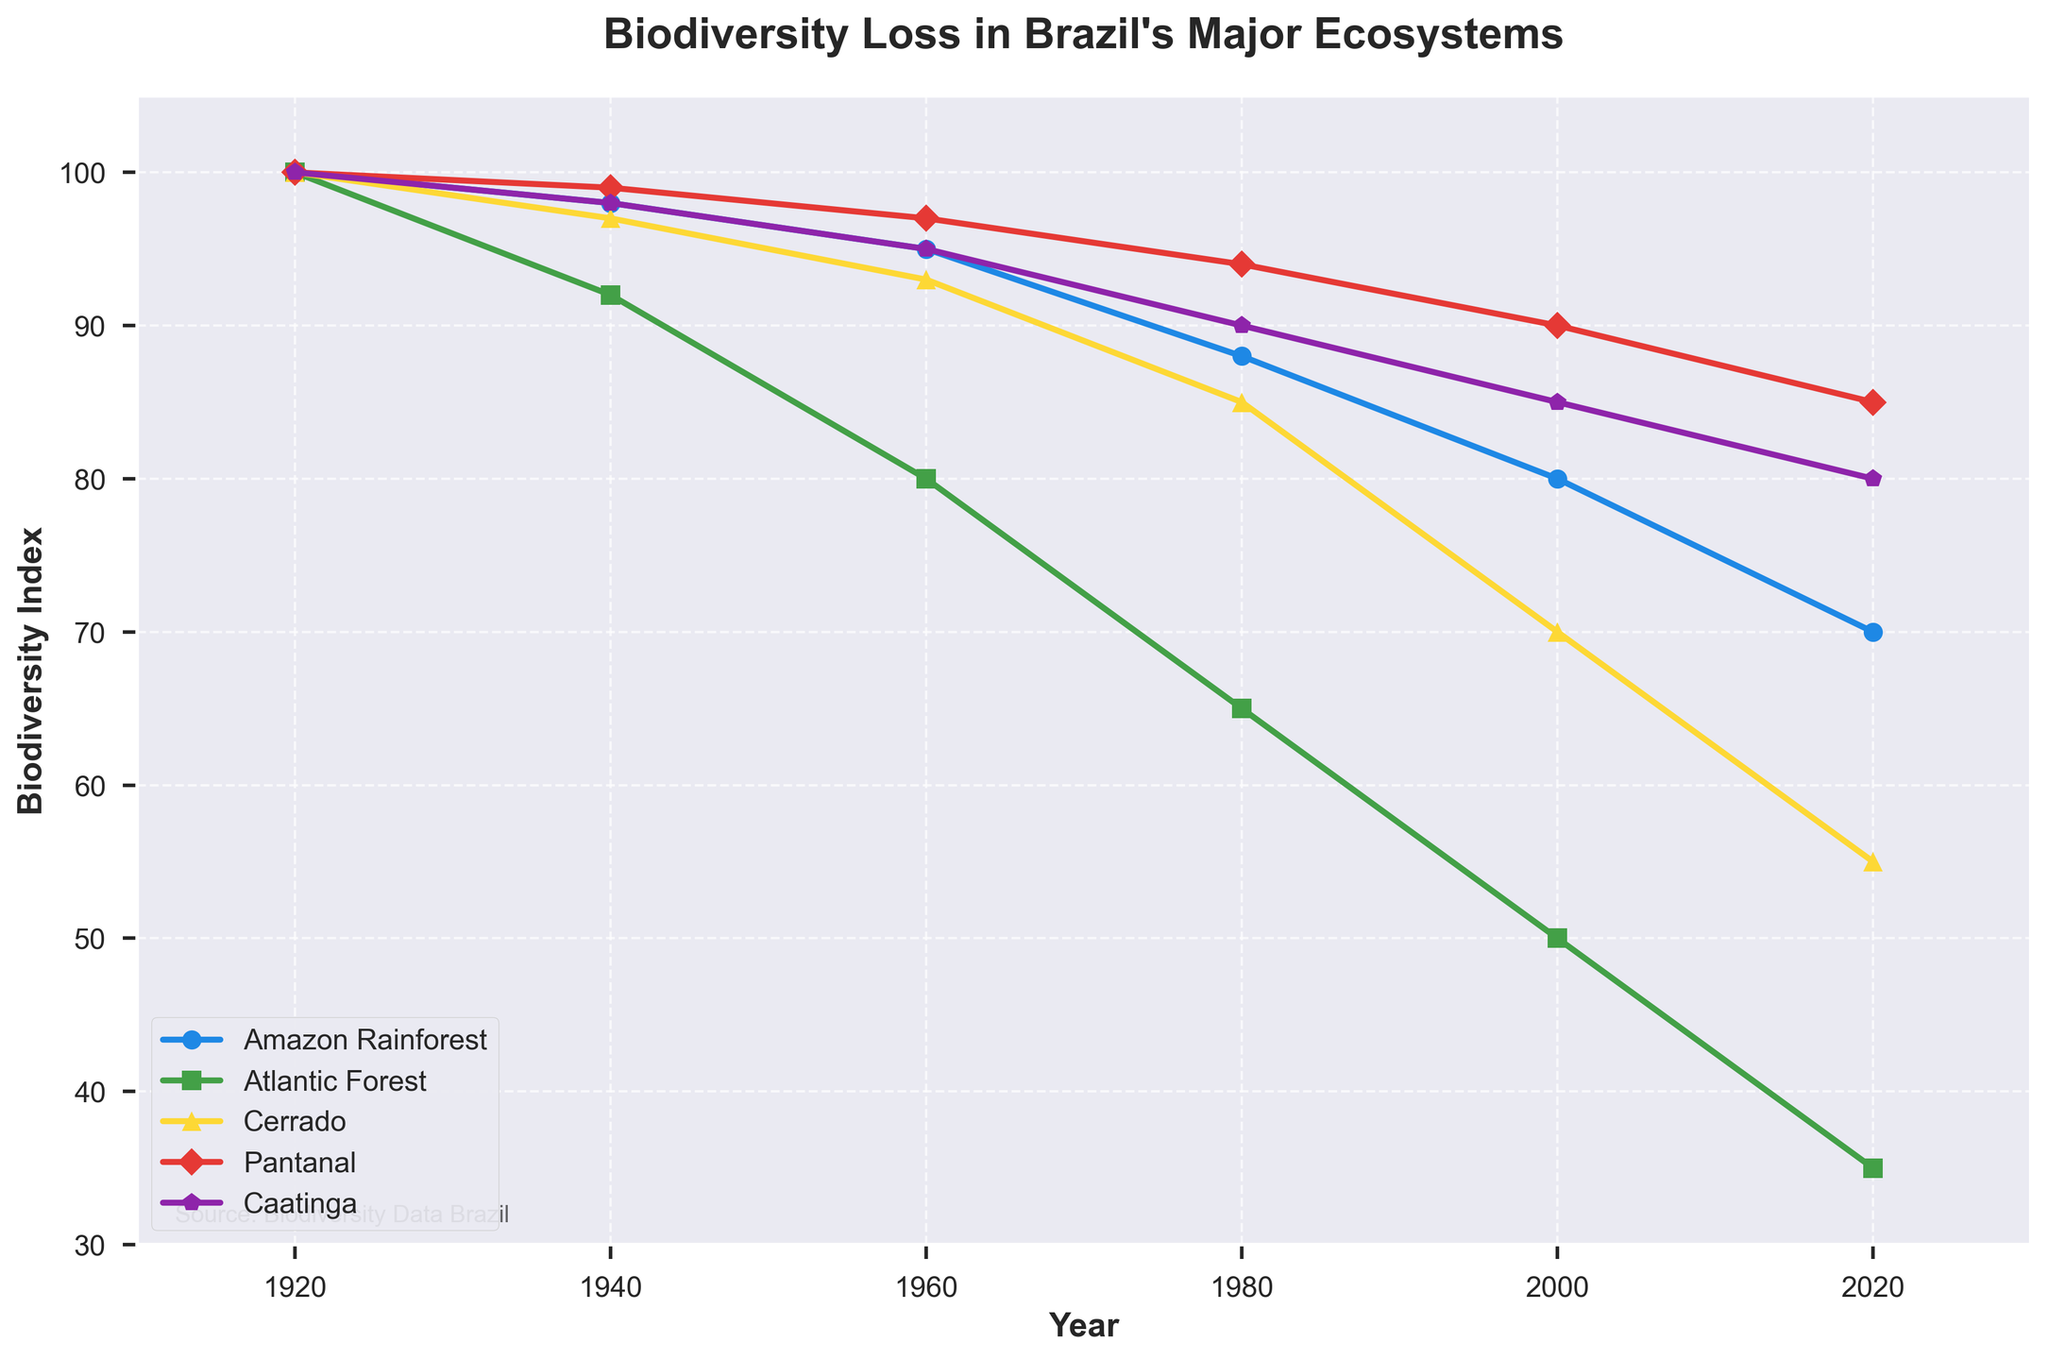What is the trend of biodiversity loss in the Amazon Rainforest over the last century? The line representing the Amazon Rainforest shows a consistent downward trend from 100 in 1920 to 70 in 2020. This indicates a steady decline in biodiversity over the last century.
Answer: A consistent downward trend Which ecosystem has the least biodiversity loss in 2020? In 2020, the Pantanal's line is the highest on the chart among all ecosystems, indicating the least biodiversity loss with an index of 85.
Answer: Pantanal How much did the biodiversity index decrease in the Atlantic Forest from 1920 to 1980? In 1920, the Atlantic Forest had a biodiversity index of 100, and by 1980, it dropped to 65. The decrease is 100 - 65 = 35.
Answer: 35 Between 1940 and 1960, which ecosystem experienced the most significant drop in biodiversity index? Comparing the slopes between 1940 and 1960, the Atlantic Forest shows the steepest decline from 92 to 80, which is a drop of 12 points.
Answer: Atlantic Forest Calculate the average biodiversity index of the Cerrado in the data provided. The biodiversity indices for the Cerrado are 100, 97, 93, 85, 70, and 55. Summing these values gives 100 + 97 + 93 + 85 + 70 + 55 = 500. There are 6 data points, so the average is 500 / 6 = 83.33.
Answer: 83.33 Which ecosystem had the steepest decline between 1960 and 1980? The declination can be evaluated by comparing the slopes: Amazon Rainforest (95 to 88), Atlantic Forest (80 to 65), Cerrado (93 to 85), Pantanal (97 to 94), Caatinga (95 to 90). The Atlantic Forest had the steepest decline from 80 to 65, which is 15 points.
Answer: Atlantic Forest As of 2020, which two ecosystems have the most similar biodiversity indices? In 2020, the Atlantic Forest has an index of 35 and the Caatinga has an index of 80, the Cerrado has 55, and the Amazon Rainforest has 70. The Pantanal has 85. The closest two are the Amazon Rainforest and the Cerrado with indices of 70 and 55, respectively.
Answer: Amazon Rainforest and Cerrado How much did the biodiversity index change for the Caatinga between 2000 and 2020? The Caatinga's biodiversity index in 2000 was 85 and dropped to 80 in 2020. The change is 85 - 80 = 5.
Answer: 5 During which period did the Pantanal experience the most rapid loss of biodiversity? The most rapid loss of biodiversity in the Pantanal, indicated by the steepest slope, occurred between 1940 and 1960, decreasing from 99 to 97.
Answer: 1940 to 1960 What is the relative decline in biodiversity from 1920 to 2020 for the Atlantic Forest? The initial index was 100 in 1920 and decreased to 35 in 2020. The relative decline is (100 - 35) / 100 = 0.65, or 65%.
Answer: 65% 